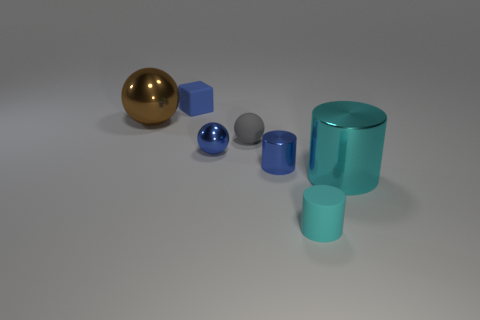Subtract 1 spheres. How many spheres are left? 2 Add 3 blue spheres. How many objects exist? 10 Subtract all blocks. How many objects are left? 6 Subtract all matte spheres. Subtract all big metal things. How many objects are left? 4 Add 1 small gray matte balls. How many small gray matte balls are left? 2 Add 4 big yellow metallic cylinders. How many big yellow metallic cylinders exist? 4 Subtract 0 brown cubes. How many objects are left? 7 